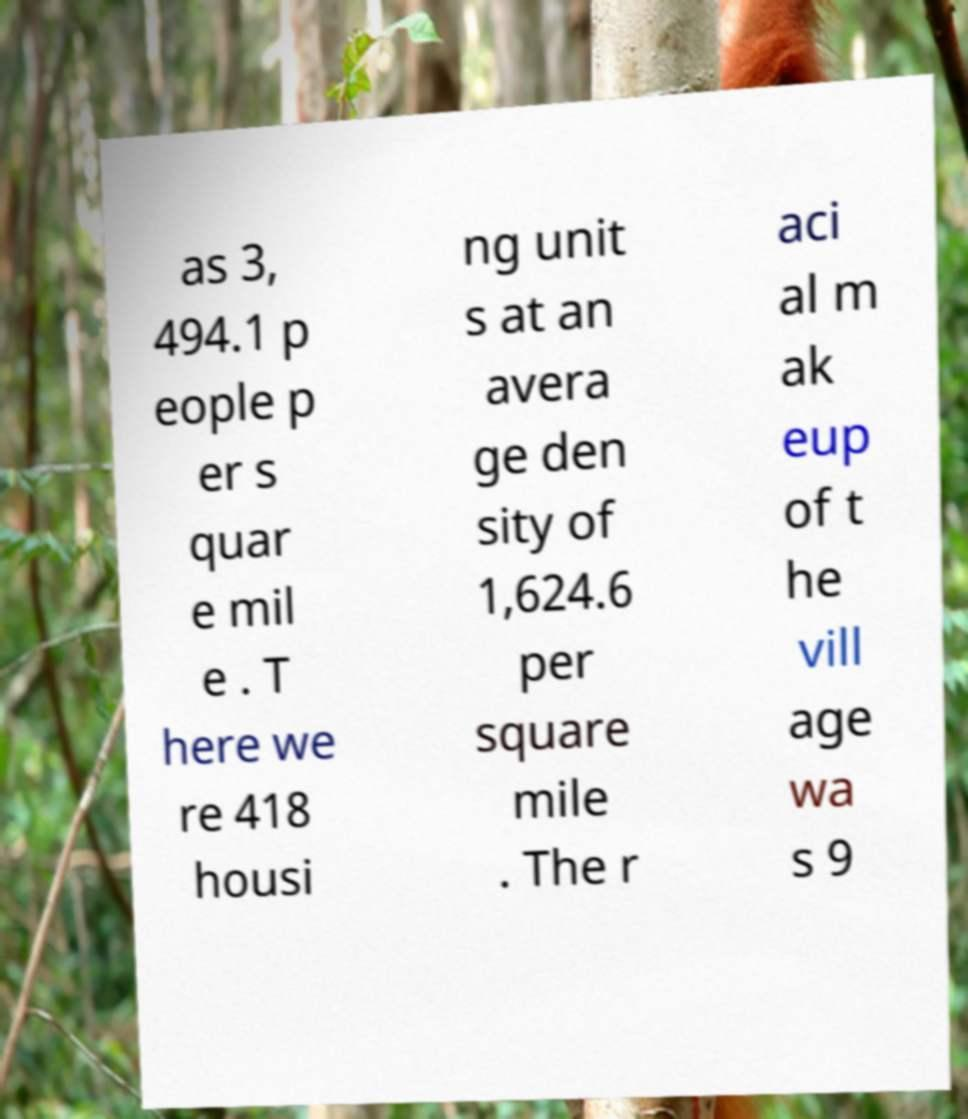Can you read and provide the text displayed in the image?This photo seems to have some interesting text. Can you extract and type it out for me? as 3, 494.1 p eople p er s quar e mil e . T here we re 418 housi ng unit s at an avera ge den sity of 1,624.6 per square mile . The r aci al m ak eup of t he vill age wa s 9 